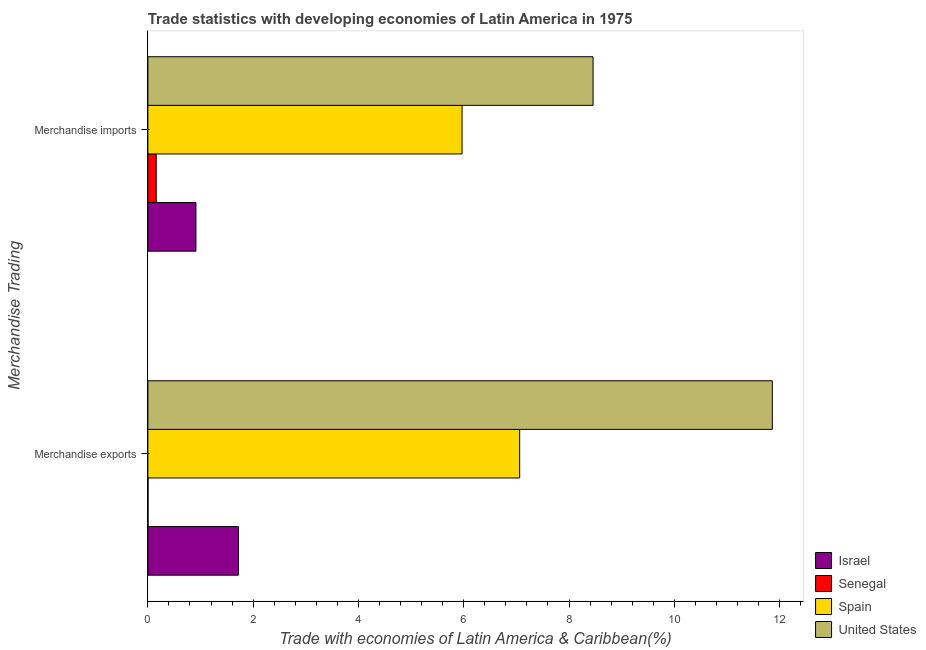How many groups of bars are there?
Give a very brief answer. 2. Are the number of bars per tick equal to the number of legend labels?
Make the answer very short. Yes. How many bars are there on the 1st tick from the top?
Provide a succinct answer. 4. What is the merchandise exports in United States?
Make the answer very short. 11.86. Across all countries, what is the maximum merchandise exports?
Provide a succinct answer. 11.86. Across all countries, what is the minimum merchandise imports?
Offer a terse response. 0.16. In which country was the merchandise exports minimum?
Your response must be concise. Senegal. What is the total merchandise exports in the graph?
Give a very brief answer. 20.65. What is the difference between the merchandise exports in Senegal and that in United States?
Give a very brief answer. -11.86. What is the difference between the merchandise imports in Spain and the merchandise exports in United States?
Offer a terse response. -5.89. What is the average merchandise imports per country?
Keep it short and to the point. 3.87. What is the difference between the merchandise imports and merchandise exports in United States?
Make the answer very short. -3.41. What is the ratio of the merchandise imports in Senegal to that in Israel?
Keep it short and to the point. 0.17. Is the merchandise imports in Senegal less than that in Israel?
Your answer should be very brief. Yes. In how many countries, is the merchandise exports greater than the average merchandise exports taken over all countries?
Keep it short and to the point. 2. What does the 3rd bar from the top in Merchandise exports represents?
Your answer should be compact. Senegal. How many countries are there in the graph?
Provide a succinct answer. 4. Does the graph contain grids?
Your answer should be very brief. No. How many legend labels are there?
Provide a short and direct response. 4. What is the title of the graph?
Ensure brevity in your answer.  Trade statistics with developing economies of Latin America in 1975. Does "Singapore" appear as one of the legend labels in the graph?
Offer a terse response. No. What is the label or title of the X-axis?
Your answer should be very brief. Trade with economies of Latin America & Caribbean(%). What is the label or title of the Y-axis?
Provide a succinct answer. Merchandise Trading. What is the Trade with economies of Latin America & Caribbean(%) in Israel in Merchandise exports?
Make the answer very short. 1.72. What is the Trade with economies of Latin America & Caribbean(%) of Senegal in Merchandise exports?
Keep it short and to the point. 0. What is the Trade with economies of Latin America & Caribbean(%) in Spain in Merchandise exports?
Keep it short and to the point. 7.06. What is the Trade with economies of Latin America & Caribbean(%) in United States in Merchandise exports?
Your answer should be very brief. 11.86. What is the Trade with economies of Latin America & Caribbean(%) in Israel in Merchandise imports?
Provide a short and direct response. 0.91. What is the Trade with economies of Latin America & Caribbean(%) of Senegal in Merchandise imports?
Offer a very short reply. 0.16. What is the Trade with economies of Latin America & Caribbean(%) in Spain in Merchandise imports?
Provide a short and direct response. 5.97. What is the Trade with economies of Latin America & Caribbean(%) in United States in Merchandise imports?
Keep it short and to the point. 8.46. Across all Merchandise Trading, what is the maximum Trade with economies of Latin America & Caribbean(%) in Israel?
Offer a terse response. 1.72. Across all Merchandise Trading, what is the maximum Trade with economies of Latin America & Caribbean(%) in Senegal?
Your answer should be compact. 0.16. Across all Merchandise Trading, what is the maximum Trade with economies of Latin America & Caribbean(%) in Spain?
Your response must be concise. 7.06. Across all Merchandise Trading, what is the maximum Trade with economies of Latin America & Caribbean(%) in United States?
Give a very brief answer. 11.86. Across all Merchandise Trading, what is the minimum Trade with economies of Latin America & Caribbean(%) in Israel?
Provide a short and direct response. 0.91. Across all Merchandise Trading, what is the minimum Trade with economies of Latin America & Caribbean(%) of Senegal?
Offer a terse response. 0. Across all Merchandise Trading, what is the minimum Trade with economies of Latin America & Caribbean(%) of Spain?
Keep it short and to the point. 5.97. Across all Merchandise Trading, what is the minimum Trade with economies of Latin America & Caribbean(%) of United States?
Make the answer very short. 8.46. What is the total Trade with economies of Latin America & Caribbean(%) of Israel in the graph?
Make the answer very short. 2.63. What is the total Trade with economies of Latin America & Caribbean(%) of Senegal in the graph?
Ensure brevity in your answer.  0.16. What is the total Trade with economies of Latin America & Caribbean(%) of Spain in the graph?
Ensure brevity in your answer.  13.03. What is the total Trade with economies of Latin America & Caribbean(%) in United States in the graph?
Give a very brief answer. 20.32. What is the difference between the Trade with economies of Latin America & Caribbean(%) of Israel in Merchandise exports and that in Merchandise imports?
Your answer should be very brief. 0.81. What is the difference between the Trade with economies of Latin America & Caribbean(%) in Senegal in Merchandise exports and that in Merchandise imports?
Provide a succinct answer. -0.16. What is the difference between the Trade with economies of Latin America & Caribbean(%) in Spain in Merchandise exports and that in Merchandise imports?
Provide a succinct answer. 1.09. What is the difference between the Trade with economies of Latin America & Caribbean(%) of United States in Merchandise exports and that in Merchandise imports?
Make the answer very short. 3.41. What is the difference between the Trade with economies of Latin America & Caribbean(%) in Israel in Merchandise exports and the Trade with economies of Latin America & Caribbean(%) in Senegal in Merchandise imports?
Provide a succinct answer. 1.56. What is the difference between the Trade with economies of Latin America & Caribbean(%) of Israel in Merchandise exports and the Trade with economies of Latin America & Caribbean(%) of Spain in Merchandise imports?
Ensure brevity in your answer.  -4.25. What is the difference between the Trade with economies of Latin America & Caribbean(%) of Israel in Merchandise exports and the Trade with economies of Latin America & Caribbean(%) of United States in Merchandise imports?
Provide a short and direct response. -6.74. What is the difference between the Trade with economies of Latin America & Caribbean(%) of Senegal in Merchandise exports and the Trade with economies of Latin America & Caribbean(%) of Spain in Merchandise imports?
Ensure brevity in your answer.  -5.97. What is the difference between the Trade with economies of Latin America & Caribbean(%) in Senegal in Merchandise exports and the Trade with economies of Latin America & Caribbean(%) in United States in Merchandise imports?
Offer a terse response. -8.45. What is the difference between the Trade with economies of Latin America & Caribbean(%) in Spain in Merchandise exports and the Trade with economies of Latin America & Caribbean(%) in United States in Merchandise imports?
Your answer should be compact. -1.39. What is the average Trade with economies of Latin America & Caribbean(%) in Israel per Merchandise Trading?
Your answer should be compact. 1.32. What is the average Trade with economies of Latin America & Caribbean(%) in Senegal per Merchandise Trading?
Your answer should be very brief. 0.08. What is the average Trade with economies of Latin America & Caribbean(%) of Spain per Merchandise Trading?
Keep it short and to the point. 6.52. What is the average Trade with economies of Latin America & Caribbean(%) in United States per Merchandise Trading?
Keep it short and to the point. 10.16. What is the difference between the Trade with economies of Latin America & Caribbean(%) of Israel and Trade with economies of Latin America & Caribbean(%) of Senegal in Merchandise exports?
Your response must be concise. 1.72. What is the difference between the Trade with economies of Latin America & Caribbean(%) of Israel and Trade with economies of Latin America & Caribbean(%) of Spain in Merchandise exports?
Ensure brevity in your answer.  -5.34. What is the difference between the Trade with economies of Latin America & Caribbean(%) of Israel and Trade with economies of Latin America & Caribbean(%) of United States in Merchandise exports?
Your answer should be compact. -10.14. What is the difference between the Trade with economies of Latin America & Caribbean(%) in Senegal and Trade with economies of Latin America & Caribbean(%) in Spain in Merchandise exports?
Give a very brief answer. -7.06. What is the difference between the Trade with economies of Latin America & Caribbean(%) of Senegal and Trade with economies of Latin America & Caribbean(%) of United States in Merchandise exports?
Keep it short and to the point. -11.86. What is the difference between the Trade with economies of Latin America & Caribbean(%) of Spain and Trade with economies of Latin America & Caribbean(%) of United States in Merchandise exports?
Offer a terse response. -4.8. What is the difference between the Trade with economies of Latin America & Caribbean(%) in Israel and Trade with economies of Latin America & Caribbean(%) in Senegal in Merchandise imports?
Your answer should be very brief. 0.75. What is the difference between the Trade with economies of Latin America & Caribbean(%) in Israel and Trade with economies of Latin America & Caribbean(%) in Spain in Merchandise imports?
Offer a terse response. -5.06. What is the difference between the Trade with economies of Latin America & Caribbean(%) of Israel and Trade with economies of Latin America & Caribbean(%) of United States in Merchandise imports?
Your answer should be very brief. -7.54. What is the difference between the Trade with economies of Latin America & Caribbean(%) of Senegal and Trade with economies of Latin America & Caribbean(%) of Spain in Merchandise imports?
Provide a succinct answer. -5.81. What is the difference between the Trade with economies of Latin America & Caribbean(%) of Senegal and Trade with economies of Latin America & Caribbean(%) of United States in Merchandise imports?
Offer a very short reply. -8.3. What is the difference between the Trade with economies of Latin America & Caribbean(%) of Spain and Trade with economies of Latin America & Caribbean(%) of United States in Merchandise imports?
Your answer should be very brief. -2.49. What is the ratio of the Trade with economies of Latin America & Caribbean(%) in Israel in Merchandise exports to that in Merchandise imports?
Keep it short and to the point. 1.88. What is the ratio of the Trade with economies of Latin America & Caribbean(%) of Senegal in Merchandise exports to that in Merchandise imports?
Keep it short and to the point. 0.02. What is the ratio of the Trade with economies of Latin America & Caribbean(%) in Spain in Merchandise exports to that in Merchandise imports?
Keep it short and to the point. 1.18. What is the ratio of the Trade with economies of Latin America & Caribbean(%) in United States in Merchandise exports to that in Merchandise imports?
Provide a succinct answer. 1.4. What is the difference between the highest and the second highest Trade with economies of Latin America & Caribbean(%) of Israel?
Your answer should be compact. 0.81. What is the difference between the highest and the second highest Trade with economies of Latin America & Caribbean(%) in Senegal?
Keep it short and to the point. 0.16. What is the difference between the highest and the second highest Trade with economies of Latin America & Caribbean(%) of Spain?
Your answer should be very brief. 1.09. What is the difference between the highest and the second highest Trade with economies of Latin America & Caribbean(%) in United States?
Provide a succinct answer. 3.41. What is the difference between the highest and the lowest Trade with economies of Latin America & Caribbean(%) of Israel?
Your answer should be compact. 0.81. What is the difference between the highest and the lowest Trade with economies of Latin America & Caribbean(%) in Senegal?
Ensure brevity in your answer.  0.16. What is the difference between the highest and the lowest Trade with economies of Latin America & Caribbean(%) of Spain?
Your response must be concise. 1.09. What is the difference between the highest and the lowest Trade with economies of Latin America & Caribbean(%) of United States?
Keep it short and to the point. 3.41. 